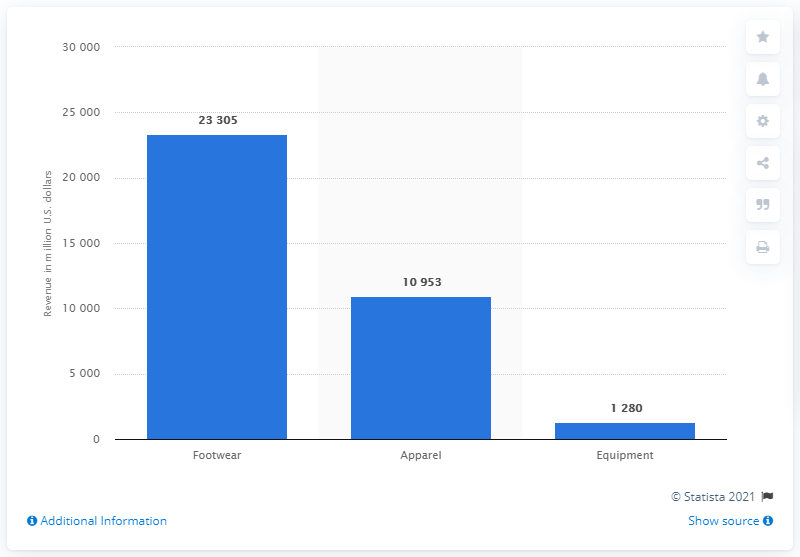Outline some significant characteristics in this image. Nike's apparel segment generated worldwide revenue of approximately 109,530 in 2020. 